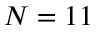Convert formula to latex. <formula><loc_0><loc_0><loc_500><loc_500>N = 1 1</formula> 